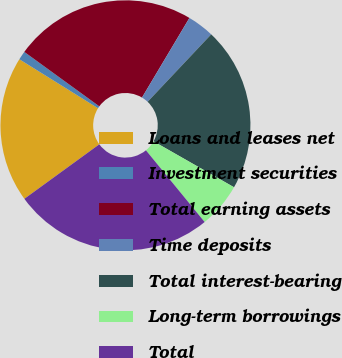<chart> <loc_0><loc_0><loc_500><loc_500><pie_chart><fcel>Loans and leases net<fcel>Investment securities<fcel>Total earning assets<fcel>Time deposits<fcel>Total interest-bearing<fcel>Long-term borrowings<fcel>Total<nl><fcel>18.87%<fcel>1.13%<fcel>23.56%<fcel>3.48%<fcel>21.22%<fcel>5.83%<fcel>25.91%<nl></chart> 